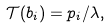Convert formula to latex. <formula><loc_0><loc_0><loc_500><loc_500>\mathcal { T } ( b _ { i } ) = p _ { i } / \lambda ,</formula> 